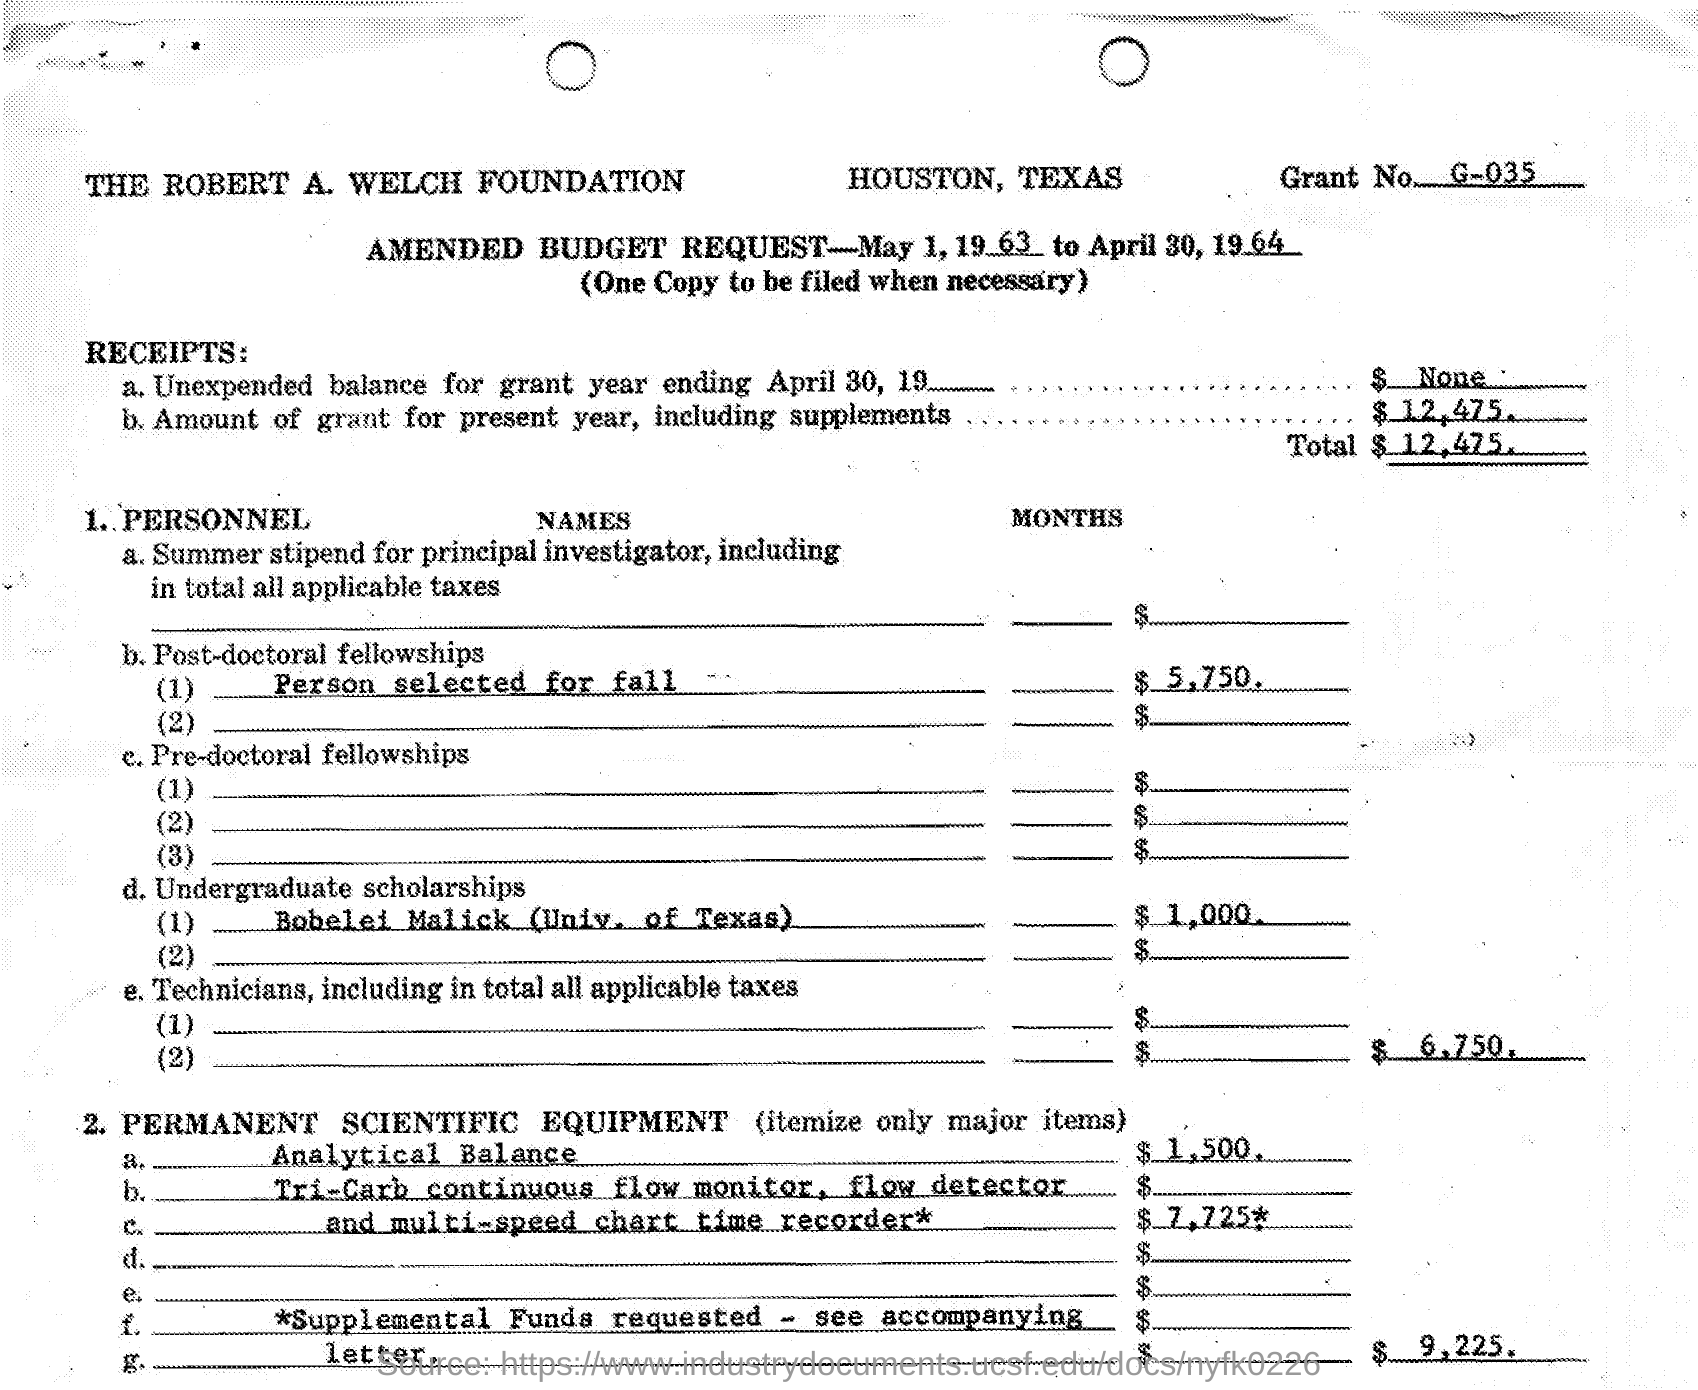Mention a couple of crucial points in this snapshot. The Robert A. Welch Foundation is mentioned. The amount of the Bobelei Malick undergraduate scholarship at the University of Texas is $1,000. The grant number is g-035.. 